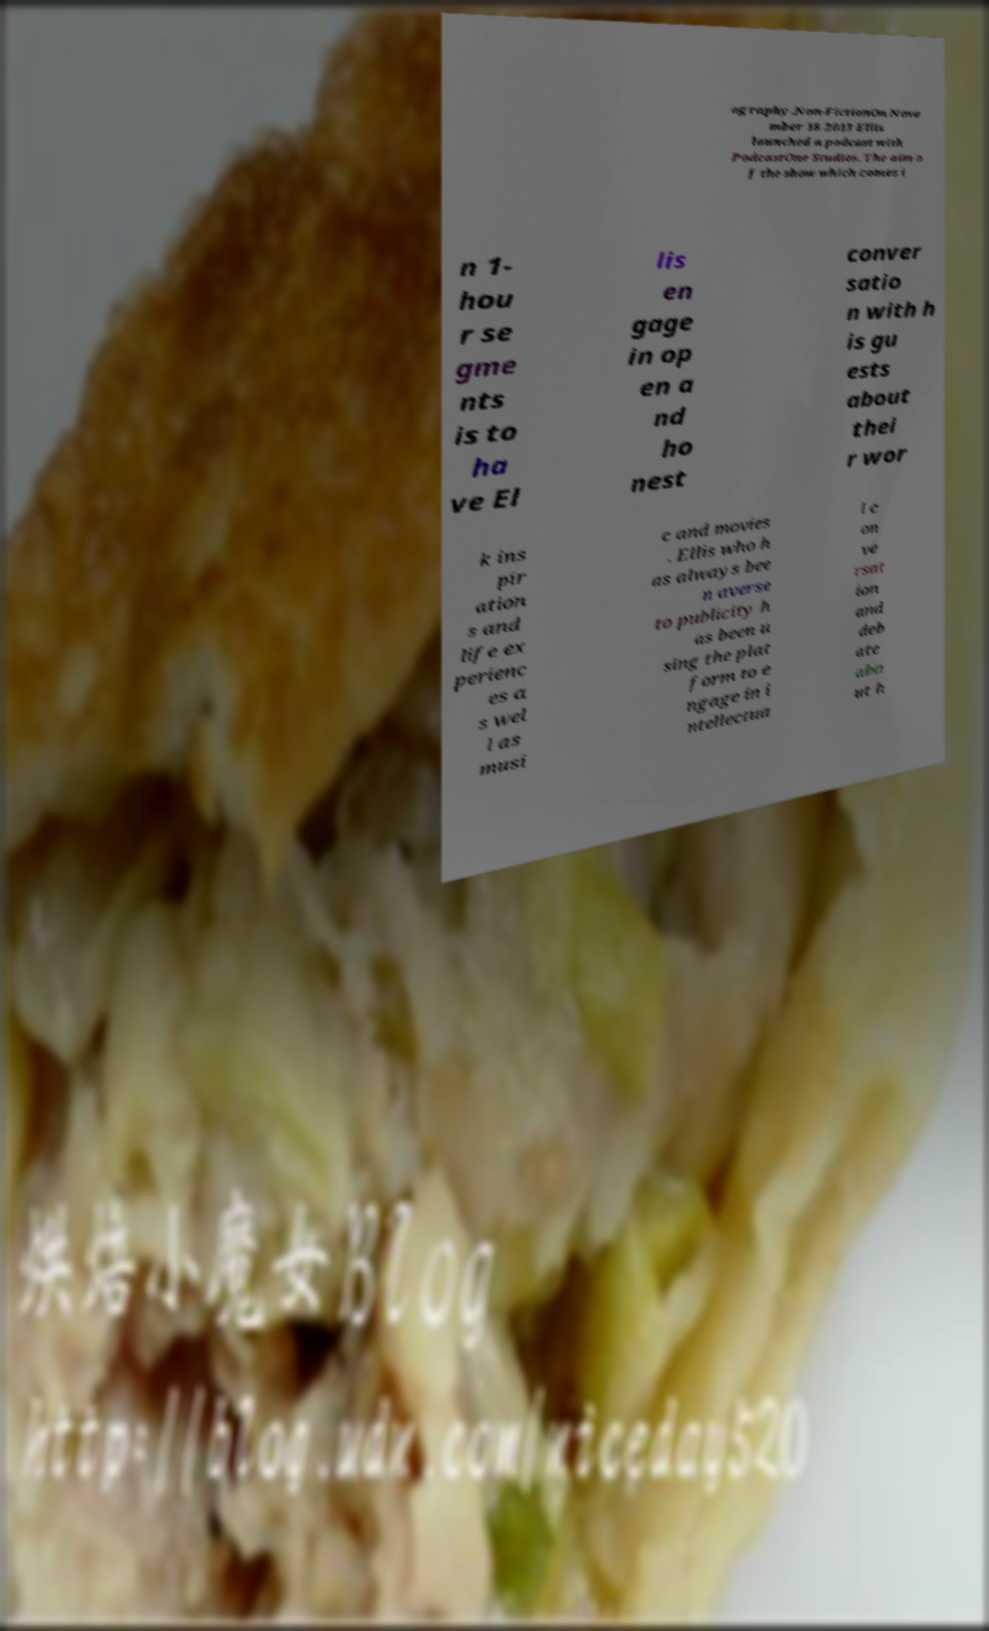Please identify and transcribe the text found in this image. ography.Non-FictionOn Nove mber 18 2013 Ellis launched a podcast with PodcastOne Studios. The aim o f the show which comes i n 1- hou r se gme nts is to ha ve El lis en gage in op en a nd ho nest conver satio n with h is gu ests about thei r wor k ins pir ation s and life ex perienc es a s wel l as musi c and movies . Ellis who h as always bee n averse to publicity h as been u sing the plat form to e ngage in i ntellectua l c on ve rsat ion and deb ate abo ut h 